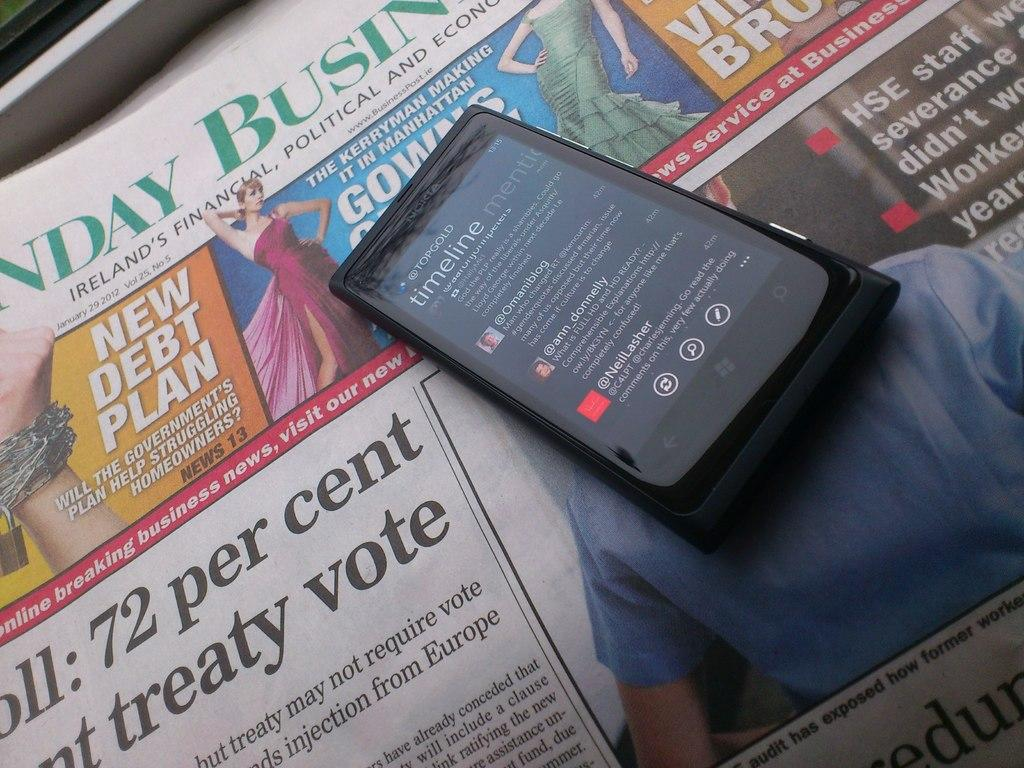<image>
Offer a succinct explanation of the picture presented. A cellphone displaying the Topgold timeline, on top of a newspaper. 